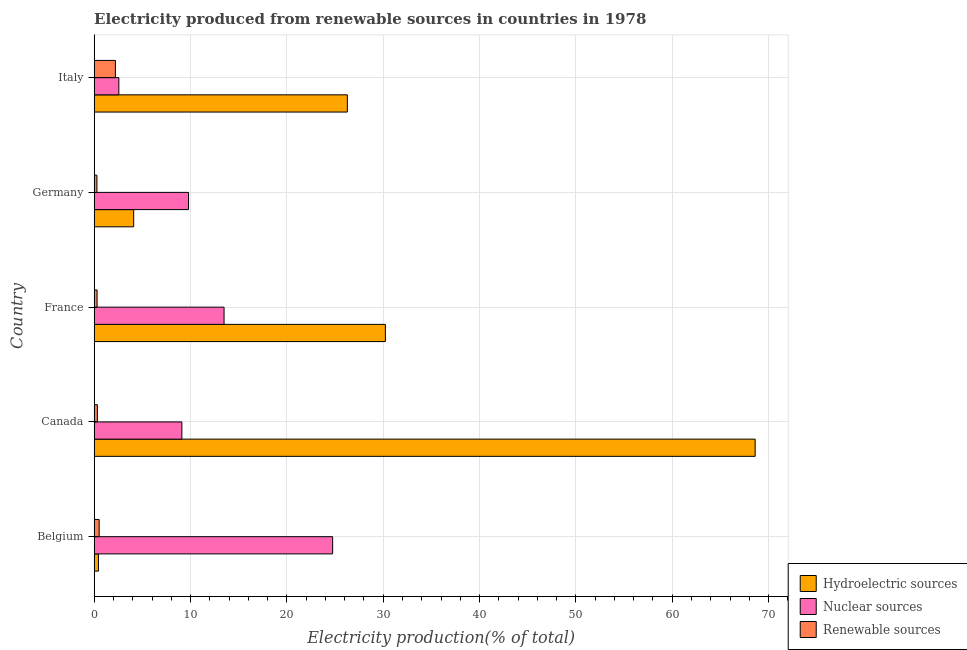Are the number of bars per tick equal to the number of legend labels?
Make the answer very short. Yes. How many bars are there on the 2nd tick from the bottom?
Your response must be concise. 3. In how many cases, is the number of bars for a given country not equal to the number of legend labels?
Your answer should be very brief. 0. What is the percentage of electricity produced by hydroelectric sources in Belgium?
Offer a very short reply. 0.44. Across all countries, what is the maximum percentage of electricity produced by renewable sources?
Keep it short and to the point. 2.2. Across all countries, what is the minimum percentage of electricity produced by hydroelectric sources?
Offer a terse response. 0.44. In which country was the percentage of electricity produced by nuclear sources maximum?
Make the answer very short. Belgium. What is the total percentage of electricity produced by renewable sources in the graph?
Ensure brevity in your answer.  3.63. What is the difference between the percentage of electricity produced by nuclear sources in Belgium and that in Germany?
Offer a very short reply. 14.96. What is the difference between the percentage of electricity produced by nuclear sources in Canada and the percentage of electricity produced by hydroelectric sources in Belgium?
Your response must be concise. 8.66. What is the average percentage of electricity produced by nuclear sources per country?
Your answer should be very brief. 11.94. What is the difference between the percentage of electricity produced by hydroelectric sources and percentage of electricity produced by renewable sources in Canada?
Give a very brief answer. 68.28. In how many countries, is the percentage of electricity produced by nuclear sources greater than 60 %?
Your response must be concise. 0. What is the ratio of the percentage of electricity produced by renewable sources in Canada to that in France?
Offer a terse response. 1.11. Is the percentage of electricity produced by nuclear sources in Germany less than that in Italy?
Give a very brief answer. No. Is the difference between the percentage of electricity produced by nuclear sources in France and Germany greater than the difference between the percentage of electricity produced by hydroelectric sources in France and Germany?
Your answer should be compact. No. What is the difference between the highest and the second highest percentage of electricity produced by nuclear sources?
Offer a very short reply. 11.27. What is the difference between the highest and the lowest percentage of electricity produced by nuclear sources?
Give a very brief answer. 22.19. What does the 2nd bar from the top in Germany represents?
Offer a terse response. Nuclear sources. What does the 1st bar from the bottom in Germany represents?
Ensure brevity in your answer.  Hydroelectric sources. Is it the case that in every country, the sum of the percentage of electricity produced by hydroelectric sources and percentage of electricity produced by nuclear sources is greater than the percentage of electricity produced by renewable sources?
Offer a terse response. Yes. Are all the bars in the graph horizontal?
Your answer should be very brief. Yes. Does the graph contain any zero values?
Your response must be concise. No. How many legend labels are there?
Your answer should be compact. 3. What is the title of the graph?
Your answer should be very brief. Electricity produced from renewable sources in countries in 1978. What is the label or title of the X-axis?
Provide a short and direct response. Electricity production(% of total). What is the Electricity production(% of total) in Hydroelectric sources in Belgium?
Your answer should be compact. 0.44. What is the Electricity production(% of total) in Nuclear sources in Belgium?
Make the answer very short. 24.75. What is the Electricity production(% of total) of Renewable sources in Belgium?
Keep it short and to the point. 0.51. What is the Electricity production(% of total) in Hydroelectric sources in Canada?
Make the answer very short. 68.61. What is the Electricity production(% of total) in Nuclear sources in Canada?
Offer a terse response. 9.1. What is the Electricity production(% of total) in Renewable sources in Canada?
Your answer should be very brief. 0.33. What is the Electricity production(% of total) of Hydroelectric sources in France?
Give a very brief answer. 30.22. What is the Electricity production(% of total) of Nuclear sources in France?
Keep it short and to the point. 13.48. What is the Electricity production(% of total) of Renewable sources in France?
Your response must be concise. 0.3. What is the Electricity production(% of total) in Hydroelectric sources in Germany?
Your answer should be very brief. 4.1. What is the Electricity production(% of total) in Nuclear sources in Germany?
Your answer should be very brief. 9.79. What is the Electricity production(% of total) of Renewable sources in Germany?
Make the answer very short. 0.28. What is the Electricity production(% of total) in Hydroelectric sources in Italy?
Offer a very short reply. 26.28. What is the Electricity production(% of total) in Nuclear sources in Italy?
Your response must be concise. 2.56. What is the Electricity production(% of total) of Renewable sources in Italy?
Make the answer very short. 2.2. Across all countries, what is the maximum Electricity production(% of total) of Hydroelectric sources?
Make the answer very short. 68.61. Across all countries, what is the maximum Electricity production(% of total) of Nuclear sources?
Your response must be concise. 24.75. Across all countries, what is the maximum Electricity production(% of total) of Renewable sources?
Your answer should be very brief. 2.2. Across all countries, what is the minimum Electricity production(% of total) of Hydroelectric sources?
Provide a short and direct response. 0.44. Across all countries, what is the minimum Electricity production(% of total) in Nuclear sources?
Ensure brevity in your answer.  2.56. Across all countries, what is the minimum Electricity production(% of total) of Renewable sources?
Offer a terse response. 0.28. What is the total Electricity production(% of total) in Hydroelectric sources in the graph?
Keep it short and to the point. 129.65. What is the total Electricity production(% of total) of Nuclear sources in the graph?
Provide a succinct answer. 59.68. What is the total Electricity production(% of total) in Renewable sources in the graph?
Provide a short and direct response. 3.63. What is the difference between the Electricity production(% of total) of Hydroelectric sources in Belgium and that in Canada?
Provide a succinct answer. -68.16. What is the difference between the Electricity production(% of total) of Nuclear sources in Belgium and that in Canada?
Ensure brevity in your answer.  15.65. What is the difference between the Electricity production(% of total) of Renewable sources in Belgium and that in Canada?
Your response must be concise. 0.18. What is the difference between the Electricity production(% of total) in Hydroelectric sources in Belgium and that in France?
Your answer should be compact. -29.78. What is the difference between the Electricity production(% of total) in Nuclear sources in Belgium and that in France?
Offer a terse response. 11.27. What is the difference between the Electricity production(% of total) in Renewable sources in Belgium and that in France?
Provide a short and direct response. 0.22. What is the difference between the Electricity production(% of total) of Hydroelectric sources in Belgium and that in Germany?
Your response must be concise. -3.66. What is the difference between the Electricity production(% of total) of Nuclear sources in Belgium and that in Germany?
Make the answer very short. 14.96. What is the difference between the Electricity production(% of total) in Renewable sources in Belgium and that in Germany?
Ensure brevity in your answer.  0.23. What is the difference between the Electricity production(% of total) of Hydroelectric sources in Belgium and that in Italy?
Provide a short and direct response. -25.84. What is the difference between the Electricity production(% of total) of Nuclear sources in Belgium and that in Italy?
Offer a very short reply. 22.19. What is the difference between the Electricity production(% of total) in Renewable sources in Belgium and that in Italy?
Keep it short and to the point. -1.69. What is the difference between the Electricity production(% of total) in Hydroelectric sources in Canada and that in France?
Provide a succinct answer. 38.38. What is the difference between the Electricity production(% of total) of Nuclear sources in Canada and that in France?
Your answer should be very brief. -4.38. What is the difference between the Electricity production(% of total) of Renewable sources in Canada and that in France?
Your response must be concise. 0.03. What is the difference between the Electricity production(% of total) in Hydroelectric sources in Canada and that in Germany?
Offer a terse response. 64.51. What is the difference between the Electricity production(% of total) of Nuclear sources in Canada and that in Germany?
Keep it short and to the point. -0.69. What is the difference between the Electricity production(% of total) in Renewable sources in Canada and that in Germany?
Give a very brief answer. 0.05. What is the difference between the Electricity production(% of total) of Hydroelectric sources in Canada and that in Italy?
Offer a terse response. 42.33. What is the difference between the Electricity production(% of total) in Nuclear sources in Canada and that in Italy?
Offer a very short reply. 6.54. What is the difference between the Electricity production(% of total) in Renewable sources in Canada and that in Italy?
Give a very brief answer. -1.87. What is the difference between the Electricity production(% of total) of Hydroelectric sources in France and that in Germany?
Provide a succinct answer. 26.13. What is the difference between the Electricity production(% of total) in Nuclear sources in France and that in Germany?
Provide a short and direct response. 3.69. What is the difference between the Electricity production(% of total) in Renewable sources in France and that in Germany?
Ensure brevity in your answer.  0.02. What is the difference between the Electricity production(% of total) of Hydroelectric sources in France and that in Italy?
Your answer should be compact. 3.95. What is the difference between the Electricity production(% of total) of Nuclear sources in France and that in Italy?
Offer a terse response. 10.92. What is the difference between the Electricity production(% of total) of Renewable sources in France and that in Italy?
Ensure brevity in your answer.  -1.9. What is the difference between the Electricity production(% of total) of Hydroelectric sources in Germany and that in Italy?
Your answer should be very brief. -22.18. What is the difference between the Electricity production(% of total) in Nuclear sources in Germany and that in Italy?
Your response must be concise. 7.24. What is the difference between the Electricity production(% of total) of Renewable sources in Germany and that in Italy?
Your answer should be very brief. -1.92. What is the difference between the Electricity production(% of total) in Hydroelectric sources in Belgium and the Electricity production(% of total) in Nuclear sources in Canada?
Give a very brief answer. -8.66. What is the difference between the Electricity production(% of total) in Hydroelectric sources in Belgium and the Electricity production(% of total) in Renewable sources in Canada?
Offer a very short reply. 0.11. What is the difference between the Electricity production(% of total) of Nuclear sources in Belgium and the Electricity production(% of total) of Renewable sources in Canada?
Your response must be concise. 24.42. What is the difference between the Electricity production(% of total) in Hydroelectric sources in Belgium and the Electricity production(% of total) in Nuclear sources in France?
Offer a very short reply. -13.04. What is the difference between the Electricity production(% of total) of Hydroelectric sources in Belgium and the Electricity production(% of total) of Renewable sources in France?
Provide a short and direct response. 0.14. What is the difference between the Electricity production(% of total) of Nuclear sources in Belgium and the Electricity production(% of total) of Renewable sources in France?
Make the answer very short. 24.45. What is the difference between the Electricity production(% of total) in Hydroelectric sources in Belgium and the Electricity production(% of total) in Nuclear sources in Germany?
Your response must be concise. -9.35. What is the difference between the Electricity production(% of total) in Hydroelectric sources in Belgium and the Electricity production(% of total) in Renewable sources in Germany?
Offer a terse response. 0.16. What is the difference between the Electricity production(% of total) of Nuclear sources in Belgium and the Electricity production(% of total) of Renewable sources in Germany?
Your answer should be very brief. 24.47. What is the difference between the Electricity production(% of total) in Hydroelectric sources in Belgium and the Electricity production(% of total) in Nuclear sources in Italy?
Provide a short and direct response. -2.12. What is the difference between the Electricity production(% of total) of Hydroelectric sources in Belgium and the Electricity production(% of total) of Renewable sources in Italy?
Provide a succinct answer. -1.76. What is the difference between the Electricity production(% of total) in Nuclear sources in Belgium and the Electricity production(% of total) in Renewable sources in Italy?
Your answer should be very brief. 22.55. What is the difference between the Electricity production(% of total) in Hydroelectric sources in Canada and the Electricity production(% of total) in Nuclear sources in France?
Your answer should be very brief. 55.13. What is the difference between the Electricity production(% of total) of Hydroelectric sources in Canada and the Electricity production(% of total) of Renewable sources in France?
Offer a terse response. 68.31. What is the difference between the Electricity production(% of total) in Nuclear sources in Canada and the Electricity production(% of total) in Renewable sources in France?
Your response must be concise. 8.8. What is the difference between the Electricity production(% of total) in Hydroelectric sources in Canada and the Electricity production(% of total) in Nuclear sources in Germany?
Provide a succinct answer. 58.81. What is the difference between the Electricity production(% of total) of Hydroelectric sources in Canada and the Electricity production(% of total) of Renewable sources in Germany?
Your answer should be compact. 68.32. What is the difference between the Electricity production(% of total) in Nuclear sources in Canada and the Electricity production(% of total) in Renewable sources in Germany?
Offer a terse response. 8.82. What is the difference between the Electricity production(% of total) of Hydroelectric sources in Canada and the Electricity production(% of total) of Nuclear sources in Italy?
Ensure brevity in your answer.  66.05. What is the difference between the Electricity production(% of total) in Hydroelectric sources in Canada and the Electricity production(% of total) in Renewable sources in Italy?
Provide a succinct answer. 66.4. What is the difference between the Electricity production(% of total) in Nuclear sources in Canada and the Electricity production(% of total) in Renewable sources in Italy?
Keep it short and to the point. 6.9. What is the difference between the Electricity production(% of total) of Hydroelectric sources in France and the Electricity production(% of total) of Nuclear sources in Germany?
Provide a succinct answer. 20.43. What is the difference between the Electricity production(% of total) in Hydroelectric sources in France and the Electricity production(% of total) in Renewable sources in Germany?
Your answer should be compact. 29.94. What is the difference between the Electricity production(% of total) of Nuclear sources in France and the Electricity production(% of total) of Renewable sources in Germany?
Provide a short and direct response. 13.2. What is the difference between the Electricity production(% of total) in Hydroelectric sources in France and the Electricity production(% of total) in Nuclear sources in Italy?
Your answer should be compact. 27.67. What is the difference between the Electricity production(% of total) of Hydroelectric sources in France and the Electricity production(% of total) of Renewable sources in Italy?
Your answer should be very brief. 28.02. What is the difference between the Electricity production(% of total) in Nuclear sources in France and the Electricity production(% of total) in Renewable sources in Italy?
Provide a short and direct response. 11.28. What is the difference between the Electricity production(% of total) of Hydroelectric sources in Germany and the Electricity production(% of total) of Nuclear sources in Italy?
Give a very brief answer. 1.54. What is the difference between the Electricity production(% of total) of Hydroelectric sources in Germany and the Electricity production(% of total) of Renewable sources in Italy?
Your response must be concise. 1.9. What is the difference between the Electricity production(% of total) of Nuclear sources in Germany and the Electricity production(% of total) of Renewable sources in Italy?
Offer a very short reply. 7.59. What is the average Electricity production(% of total) of Hydroelectric sources per country?
Give a very brief answer. 25.93. What is the average Electricity production(% of total) in Nuclear sources per country?
Your answer should be very brief. 11.94. What is the average Electricity production(% of total) of Renewable sources per country?
Ensure brevity in your answer.  0.73. What is the difference between the Electricity production(% of total) of Hydroelectric sources and Electricity production(% of total) of Nuclear sources in Belgium?
Your answer should be compact. -24.31. What is the difference between the Electricity production(% of total) in Hydroelectric sources and Electricity production(% of total) in Renewable sources in Belgium?
Your answer should be compact. -0.07. What is the difference between the Electricity production(% of total) of Nuclear sources and Electricity production(% of total) of Renewable sources in Belgium?
Ensure brevity in your answer.  24.24. What is the difference between the Electricity production(% of total) of Hydroelectric sources and Electricity production(% of total) of Nuclear sources in Canada?
Provide a short and direct response. 59.51. What is the difference between the Electricity production(% of total) in Hydroelectric sources and Electricity production(% of total) in Renewable sources in Canada?
Provide a succinct answer. 68.28. What is the difference between the Electricity production(% of total) in Nuclear sources and Electricity production(% of total) in Renewable sources in Canada?
Provide a succinct answer. 8.77. What is the difference between the Electricity production(% of total) in Hydroelectric sources and Electricity production(% of total) in Nuclear sources in France?
Your response must be concise. 16.74. What is the difference between the Electricity production(% of total) in Hydroelectric sources and Electricity production(% of total) in Renewable sources in France?
Offer a terse response. 29.92. What is the difference between the Electricity production(% of total) of Nuclear sources and Electricity production(% of total) of Renewable sources in France?
Give a very brief answer. 13.18. What is the difference between the Electricity production(% of total) in Hydroelectric sources and Electricity production(% of total) in Nuclear sources in Germany?
Keep it short and to the point. -5.7. What is the difference between the Electricity production(% of total) of Hydroelectric sources and Electricity production(% of total) of Renewable sources in Germany?
Provide a short and direct response. 3.82. What is the difference between the Electricity production(% of total) in Nuclear sources and Electricity production(% of total) in Renewable sources in Germany?
Provide a succinct answer. 9.51. What is the difference between the Electricity production(% of total) of Hydroelectric sources and Electricity production(% of total) of Nuclear sources in Italy?
Your answer should be compact. 23.72. What is the difference between the Electricity production(% of total) of Hydroelectric sources and Electricity production(% of total) of Renewable sources in Italy?
Your response must be concise. 24.08. What is the difference between the Electricity production(% of total) in Nuclear sources and Electricity production(% of total) in Renewable sources in Italy?
Provide a succinct answer. 0.36. What is the ratio of the Electricity production(% of total) in Hydroelectric sources in Belgium to that in Canada?
Your response must be concise. 0.01. What is the ratio of the Electricity production(% of total) of Nuclear sources in Belgium to that in Canada?
Give a very brief answer. 2.72. What is the ratio of the Electricity production(% of total) in Renewable sources in Belgium to that in Canada?
Make the answer very short. 1.56. What is the ratio of the Electricity production(% of total) in Hydroelectric sources in Belgium to that in France?
Offer a terse response. 0.01. What is the ratio of the Electricity production(% of total) of Nuclear sources in Belgium to that in France?
Give a very brief answer. 1.84. What is the ratio of the Electricity production(% of total) in Renewable sources in Belgium to that in France?
Your answer should be very brief. 1.72. What is the ratio of the Electricity production(% of total) of Hydroelectric sources in Belgium to that in Germany?
Make the answer very short. 0.11. What is the ratio of the Electricity production(% of total) of Nuclear sources in Belgium to that in Germany?
Your response must be concise. 2.53. What is the ratio of the Electricity production(% of total) of Renewable sources in Belgium to that in Germany?
Offer a very short reply. 1.82. What is the ratio of the Electricity production(% of total) in Hydroelectric sources in Belgium to that in Italy?
Your answer should be very brief. 0.02. What is the ratio of the Electricity production(% of total) of Nuclear sources in Belgium to that in Italy?
Offer a terse response. 9.68. What is the ratio of the Electricity production(% of total) in Renewable sources in Belgium to that in Italy?
Offer a terse response. 0.23. What is the ratio of the Electricity production(% of total) of Hydroelectric sources in Canada to that in France?
Your answer should be very brief. 2.27. What is the ratio of the Electricity production(% of total) of Nuclear sources in Canada to that in France?
Provide a short and direct response. 0.68. What is the ratio of the Electricity production(% of total) of Renewable sources in Canada to that in France?
Offer a very short reply. 1.11. What is the ratio of the Electricity production(% of total) in Hydroelectric sources in Canada to that in Germany?
Provide a short and direct response. 16.74. What is the ratio of the Electricity production(% of total) of Nuclear sources in Canada to that in Germany?
Your answer should be very brief. 0.93. What is the ratio of the Electricity production(% of total) of Renewable sources in Canada to that in Germany?
Offer a terse response. 1.17. What is the ratio of the Electricity production(% of total) of Hydroelectric sources in Canada to that in Italy?
Make the answer very short. 2.61. What is the ratio of the Electricity production(% of total) in Nuclear sources in Canada to that in Italy?
Provide a succinct answer. 3.56. What is the ratio of the Electricity production(% of total) in Renewable sources in Canada to that in Italy?
Offer a terse response. 0.15. What is the ratio of the Electricity production(% of total) of Hydroelectric sources in France to that in Germany?
Keep it short and to the point. 7.38. What is the ratio of the Electricity production(% of total) in Nuclear sources in France to that in Germany?
Give a very brief answer. 1.38. What is the ratio of the Electricity production(% of total) of Renewable sources in France to that in Germany?
Offer a terse response. 1.06. What is the ratio of the Electricity production(% of total) of Hydroelectric sources in France to that in Italy?
Provide a succinct answer. 1.15. What is the ratio of the Electricity production(% of total) of Nuclear sources in France to that in Italy?
Keep it short and to the point. 5.27. What is the ratio of the Electricity production(% of total) in Renewable sources in France to that in Italy?
Keep it short and to the point. 0.14. What is the ratio of the Electricity production(% of total) of Hydroelectric sources in Germany to that in Italy?
Provide a succinct answer. 0.16. What is the ratio of the Electricity production(% of total) in Nuclear sources in Germany to that in Italy?
Your response must be concise. 3.83. What is the ratio of the Electricity production(% of total) in Renewable sources in Germany to that in Italy?
Offer a very short reply. 0.13. What is the difference between the highest and the second highest Electricity production(% of total) in Hydroelectric sources?
Give a very brief answer. 38.38. What is the difference between the highest and the second highest Electricity production(% of total) of Nuclear sources?
Keep it short and to the point. 11.27. What is the difference between the highest and the second highest Electricity production(% of total) of Renewable sources?
Give a very brief answer. 1.69. What is the difference between the highest and the lowest Electricity production(% of total) of Hydroelectric sources?
Your answer should be compact. 68.16. What is the difference between the highest and the lowest Electricity production(% of total) of Nuclear sources?
Your answer should be very brief. 22.19. What is the difference between the highest and the lowest Electricity production(% of total) of Renewable sources?
Make the answer very short. 1.92. 